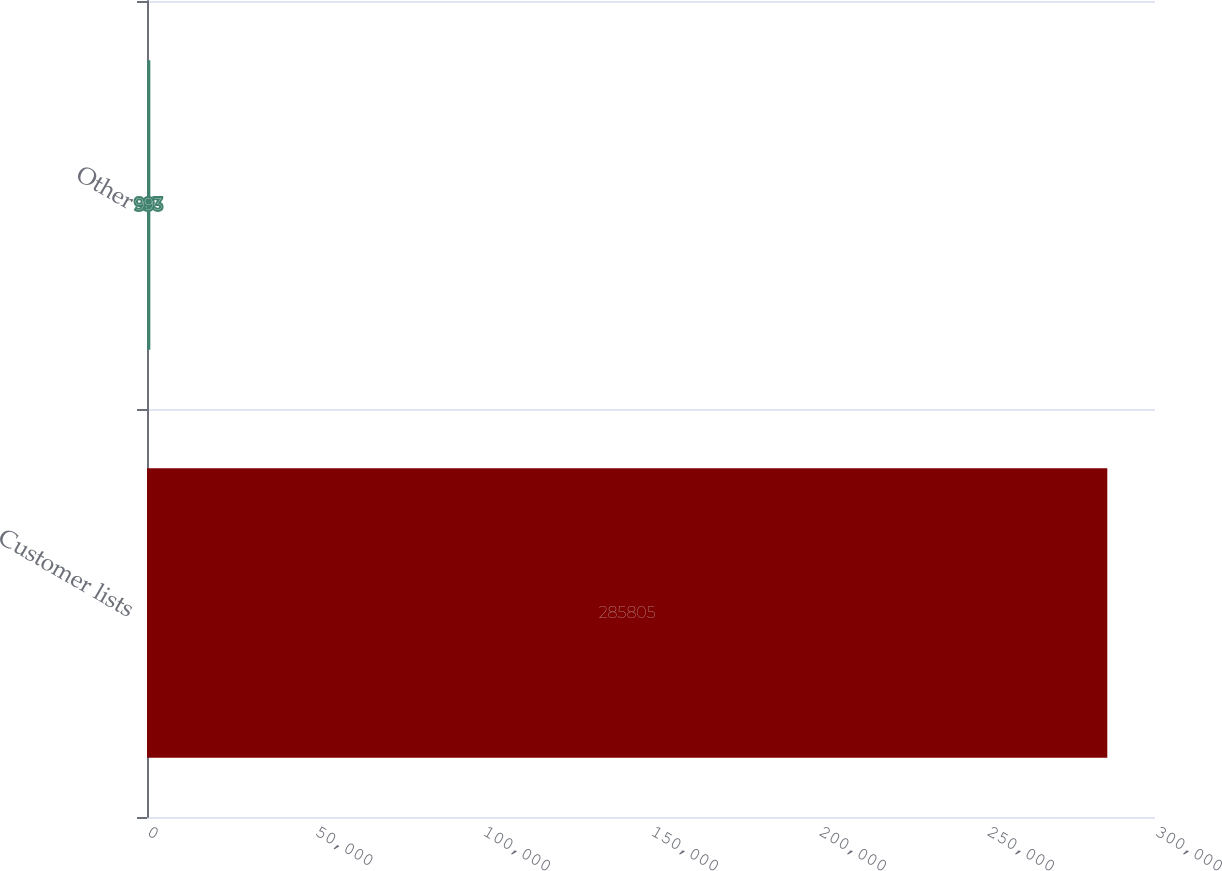<chart> <loc_0><loc_0><loc_500><loc_500><bar_chart><fcel>Customer lists<fcel>Other<nl><fcel>285805<fcel>993<nl></chart> 